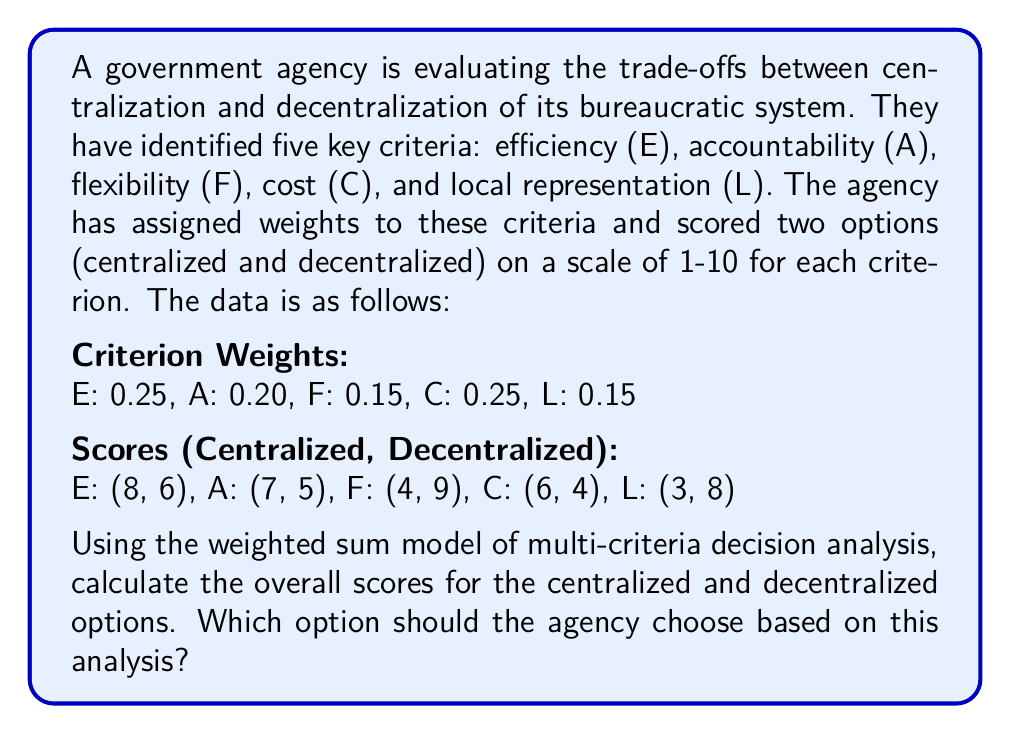Could you help me with this problem? To solve this problem, we'll use the weighted sum model of multi-criteria decision analysis. This method involves multiplying each criterion score by its weight and then summing these products for each option.

Let's calculate the weighted scores for each criterion:

1. Efficiency (E):
   Centralized: $0.25 \times 8 = 2.00$
   Decentralized: $0.25 \times 6 = 1.50$

2. Accountability (A):
   Centralized: $0.20 \times 7 = 1.40$
   Decentralized: $0.20 \times 5 = 1.00$

3. Flexibility (F):
   Centralized: $0.15 \times 4 = 0.60$
   Decentralized: $0.15 \times 9 = 1.35$

4. Cost (C):
   Centralized: $0.25 \times 6 = 1.50$
   Decentralized: $0.25 \times 4 = 1.00$

5. Local Representation (L):
   Centralized: $0.15 \times 3 = 0.45$
   Decentralized: $0.15 \times 8 = 1.20$

Now, we sum the weighted scores for each option:

Centralized option:
$$2.00 + 1.40 + 0.60 + 1.50 + 0.45 = 5.95$$

Decentralized option:
$$1.50 + 1.00 + 1.35 + 1.00 + 1.20 = 6.05$$

The decentralized option has a higher overall score (6.05) compared to the centralized option (5.95).
Answer: The overall scores are 5.95 for the centralized option and 6.05 for the decentralized option. Based on this multi-criteria decision analysis, the agency should choose the decentralized option as it has a higher overall score. 